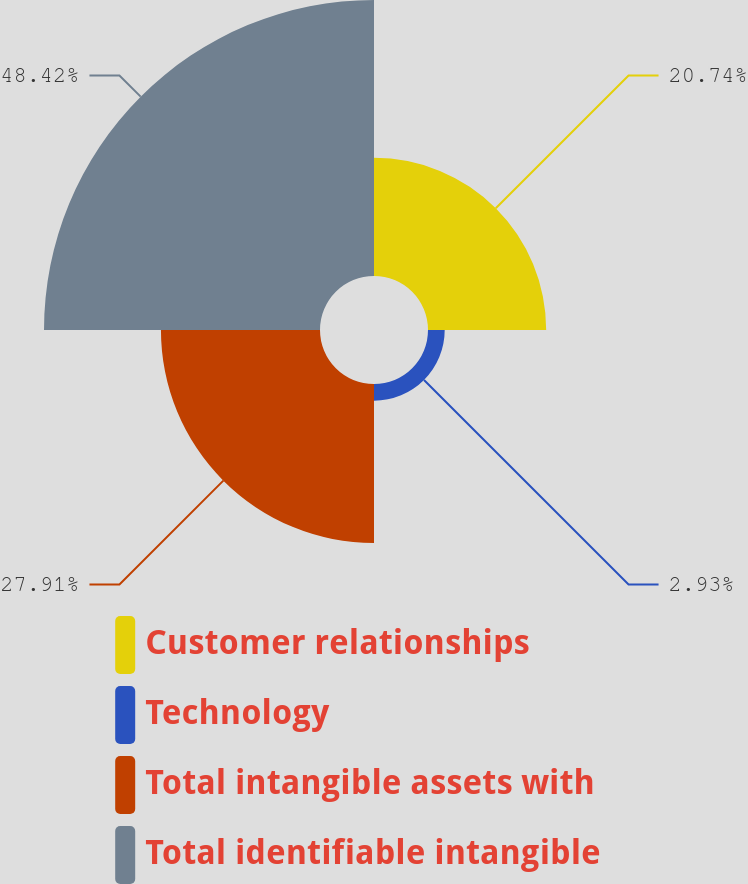Convert chart to OTSL. <chart><loc_0><loc_0><loc_500><loc_500><pie_chart><fcel>Customer relationships<fcel>Technology<fcel>Total intangible assets with<fcel>Total identifiable intangible<nl><fcel>20.74%<fcel>2.93%<fcel>27.91%<fcel>48.43%<nl></chart> 